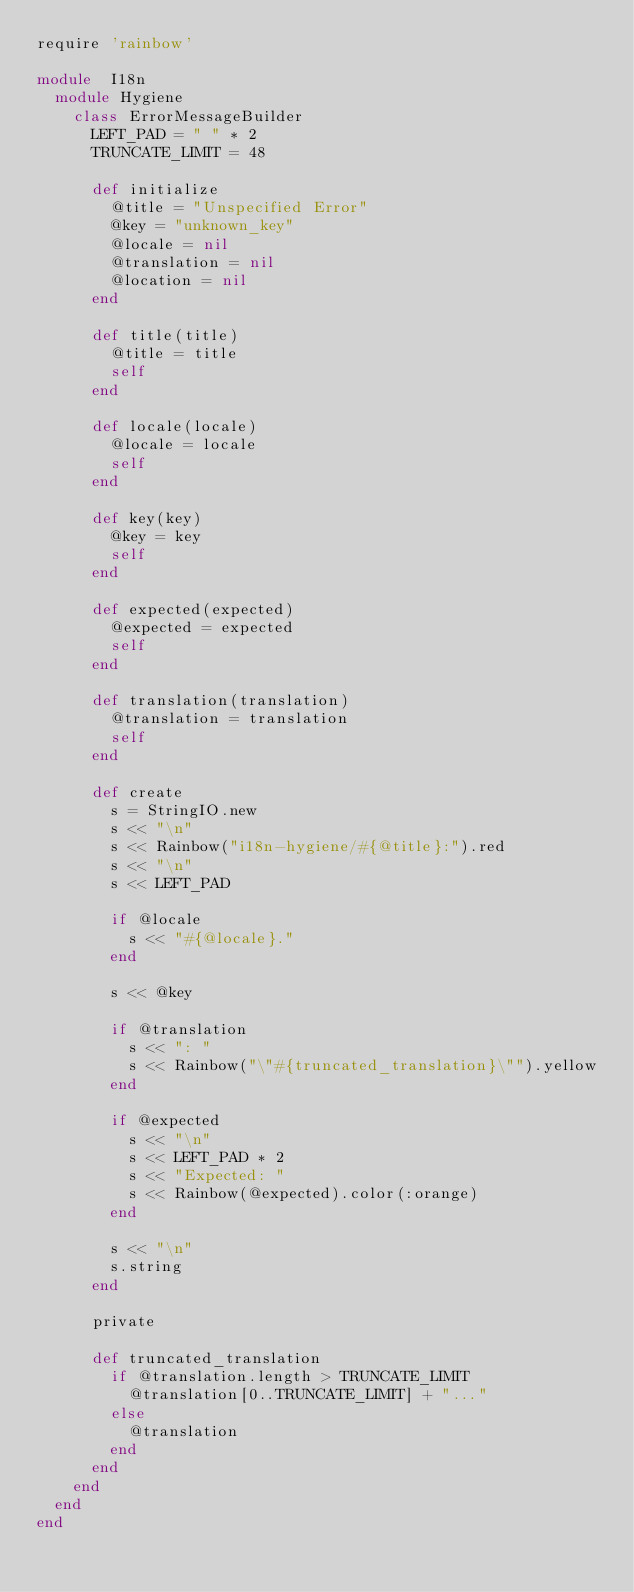Convert code to text. <code><loc_0><loc_0><loc_500><loc_500><_Ruby_>require 'rainbow'

module  I18n
  module Hygiene
    class ErrorMessageBuilder
      LEFT_PAD = " " * 2
      TRUNCATE_LIMIT = 48

      def initialize
        @title = "Unspecified Error"
        @key = "unknown_key"
        @locale = nil
        @translation = nil
        @location = nil
      end

      def title(title)
        @title = title
        self
      end

      def locale(locale)
        @locale = locale
        self
      end

      def key(key)
        @key = key
        self
      end

      def expected(expected)
        @expected = expected
        self
      end

      def translation(translation)
        @translation = translation
        self
      end

      def create
        s = StringIO.new
        s << "\n"
        s << Rainbow("i18n-hygiene/#{@title}:").red
        s << "\n"
        s << LEFT_PAD

        if @locale
          s << "#{@locale}."
        end

        s << @key

        if @translation
          s << ": "
          s << Rainbow("\"#{truncated_translation}\"").yellow
        end

        if @expected
          s << "\n"
          s << LEFT_PAD * 2
          s << "Expected: "
          s << Rainbow(@expected).color(:orange)
        end

        s << "\n"
        s.string
      end

      private

      def truncated_translation
        if @translation.length > TRUNCATE_LIMIT
          @translation[0..TRUNCATE_LIMIT] + "..."
        else
          @translation
        end
      end
    end
  end
end
</code> 